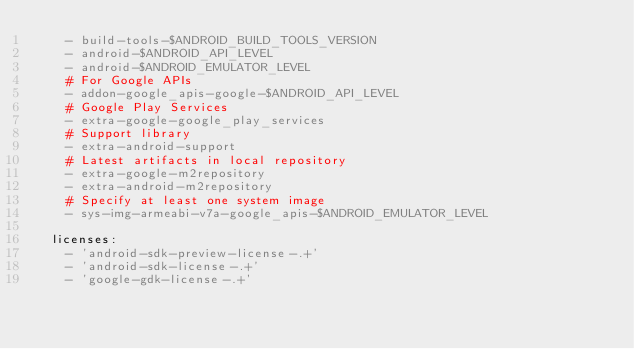Convert code to text. <code><loc_0><loc_0><loc_500><loc_500><_YAML_>    - build-tools-$ANDROID_BUILD_TOOLS_VERSION
    - android-$ANDROID_API_LEVEL
    - android-$ANDROID_EMULATOR_LEVEL
    # For Google APIs
    - addon-google_apis-google-$ANDROID_API_LEVEL
    # Google Play Services
    - extra-google-google_play_services
    # Support library
    - extra-android-support
    # Latest artifacts in local repository
    - extra-google-m2repository
    - extra-android-m2repository
    # Specify at least one system image
    - sys-img-armeabi-v7a-google_apis-$ANDROID_EMULATOR_LEVEL

  licenses:
    - 'android-sdk-preview-license-.+'
    - 'android-sdk-license-.+'
    - 'google-gdk-license-.+'</code> 